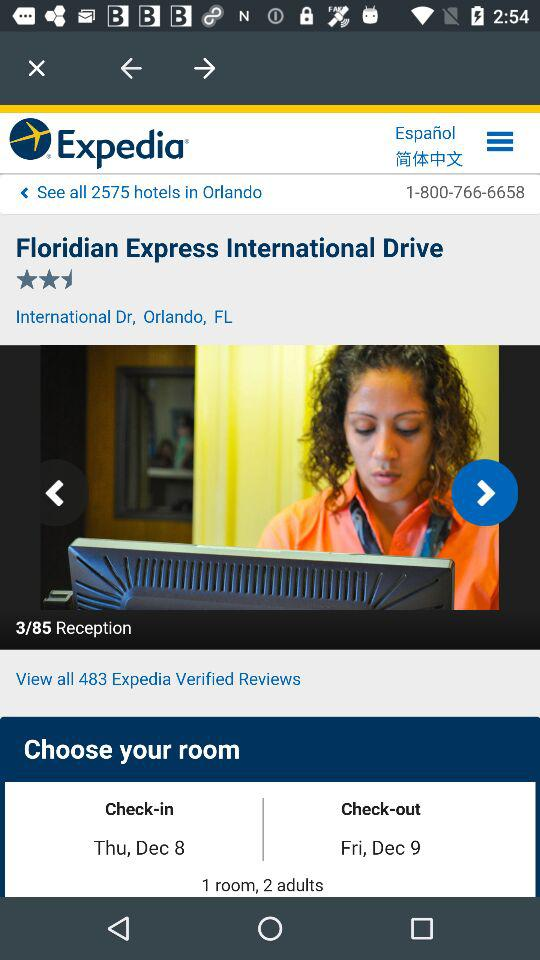What's the check-in date? The check-in date is Thursday, December 8. 